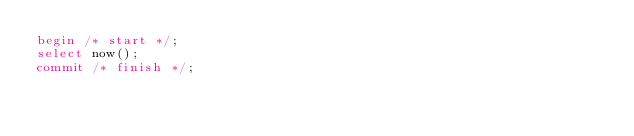Convert code to text. <code><loc_0><loc_0><loc_500><loc_500><_SQL_>begin /* start */;
select now();
commit /* finish */;
</code> 